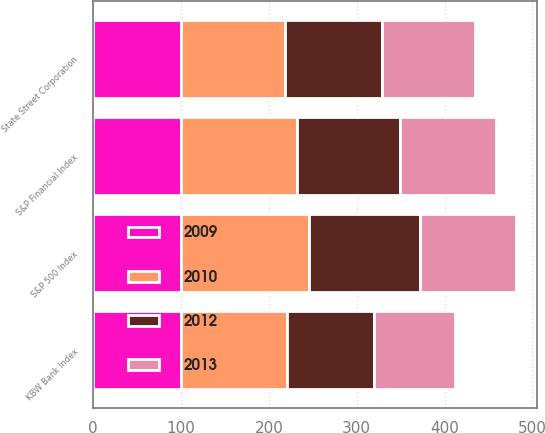<chart> <loc_0><loc_0><loc_500><loc_500><stacked_bar_chart><ecel><fcel>State Street Corporation<fcel>S&P 500 Index<fcel>S&P Financial Index<fcel>KBW Bank Index<nl><fcel>2009<fcel>100<fcel>100<fcel>100<fcel>100<nl><fcel>2012<fcel>111<fcel>126<fcel>117<fcel>98<nl><fcel>2010<fcel>118<fcel>146<fcel>132<fcel>121<nl><fcel>2013<fcel>105<fcel>109<fcel>109<fcel>93<nl></chart> 